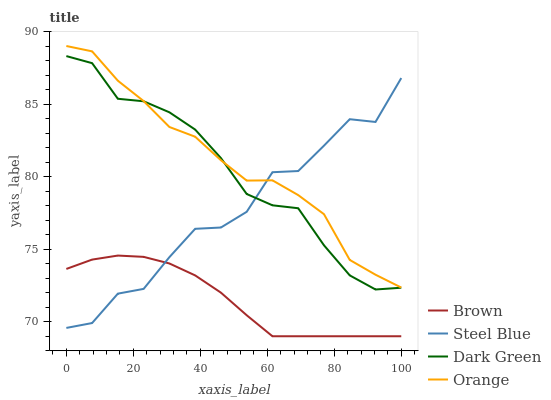Does Steel Blue have the minimum area under the curve?
Answer yes or no. No. Does Steel Blue have the maximum area under the curve?
Answer yes or no. No. Is Steel Blue the smoothest?
Answer yes or no. No. Is Brown the roughest?
Answer yes or no. No. Does Steel Blue have the lowest value?
Answer yes or no. No. Does Steel Blue have the highest value?
Answer yes or no. No. Is Brown less than Dark Green?
Answer yes or no. Yes. Is Dark Green greater than Brown?
Answer yes or no. Yes. Does Brown intersect Dark Green?
Answer yes or no. No. 